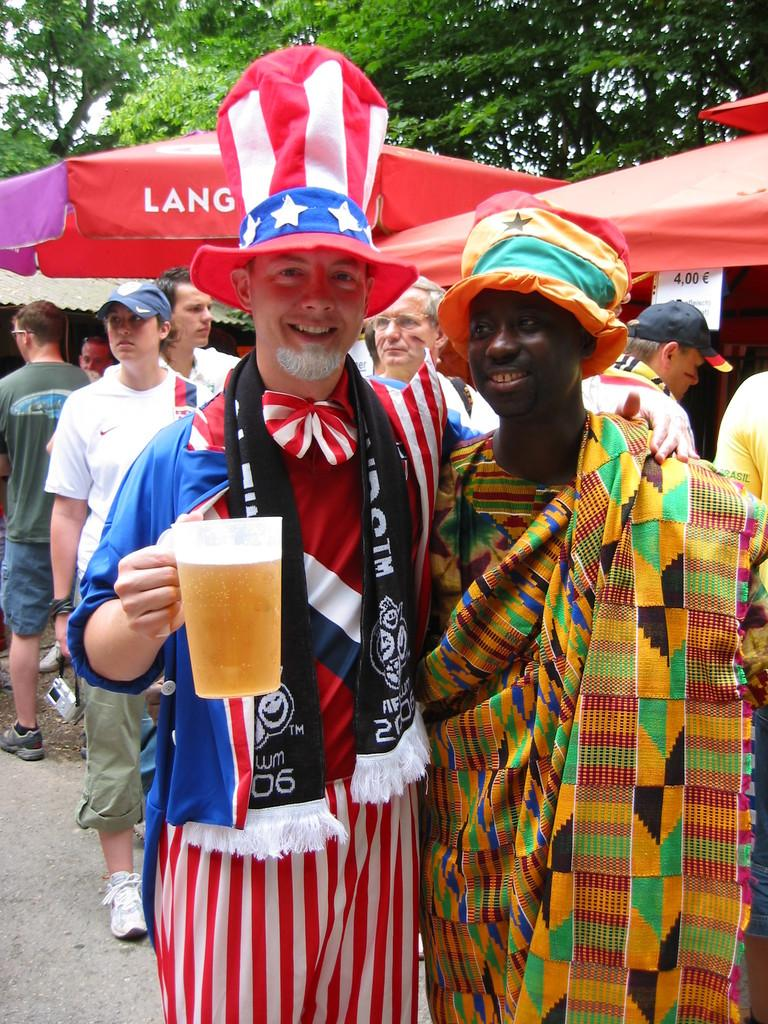<image>
Create a compact narrative representing the image presented. a man wearing an uncle sam costume with the year 2006 on his scarf 